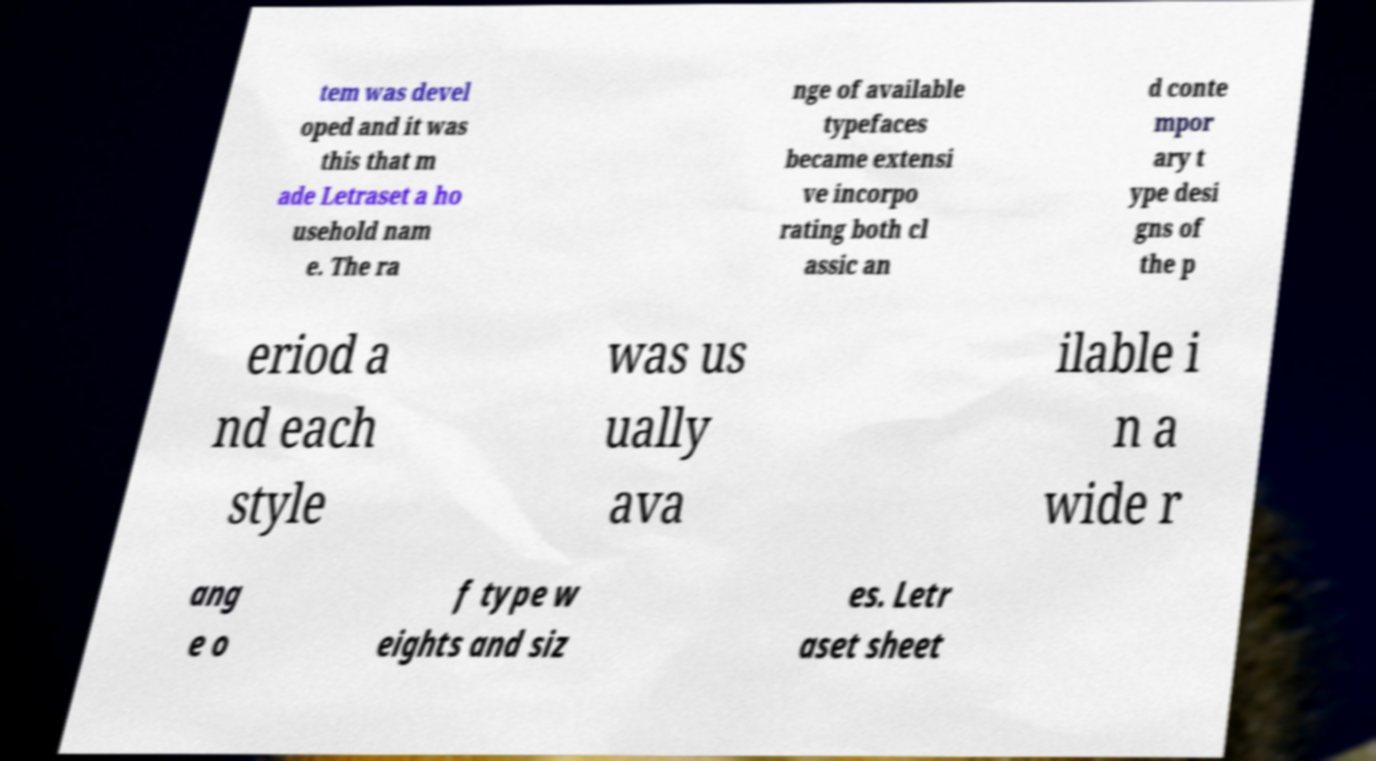Could you extract and type out the text from this image? tem was devel oped and it was this that m ade Letraset a ho usehold nam e. The ra nge of available typefaces became extensi ve incorpo rating both cl assic an d conte mpor ary t ype desi gns of the p eriod a nd each style was us ually ava ilable i n a wide r ang e o f type w eights and siz es. Letr aset sheet 